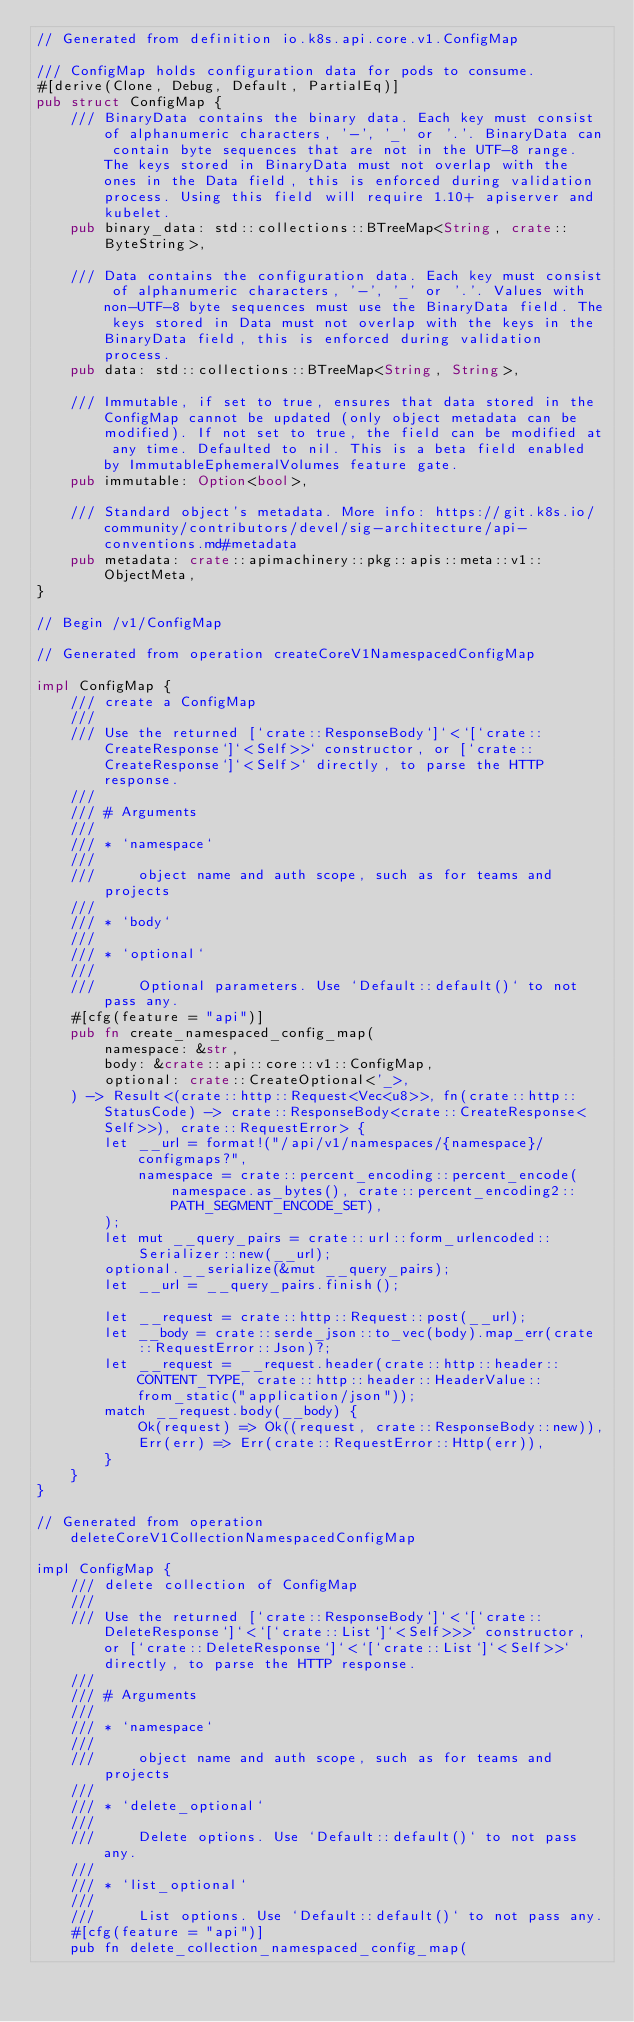<code> <loc_0><loc_0><loc_500><loc_500><_Rust_>// Generated from definition io.k8s.api.core.v1.ConfigMap

/// ConfigMap holds configuration data for pods to consume.
#[derive(Clone, Debug, Default, PartialEq)]
pub struct ConfigMap {
    /// BinaryData contains the binary data. Each key must consist of alphanumeric characters, '-', '_' or '.'. BinaryData can contain byte sequences that are not in the UTF-8 range. The keys stored in BinaryData must not overlap with the ones in the Data field, this is enforced during validation process. Using this field will require 1.10+ apiserver and kubelet.
    pub binary_data: std::collections::BTreeMap<String, crate::ByteString>,

    /// Data contains the configuration data. Each key must consist of alphanumeric characters, '-', '_' or '.'. Values with non-UTF-8 byte sequences must use the BinaryData field. The keys stored in Data must not overlap with the keys in the BinaryData field, this is enforced during validation process.
    pub data: std::collections::BTreeMap<String, String>,

    /// Immutable, if set to true, ensures that data stored in the ConfigMap cannot be updated (only object metadata can be modified). If not set to true, the field can be modified at any time. Defaulted to nil. This is a beta field enabled by ImmutableEphemeralVolumes feature gate.
    pub immutable: Option<bool>,

    /// Standard object's metadata. More info: https://git.k8s.io/community/contributors/devel/sig-architecture/api-conventions.md#metadata
    pub metadata: crate::apimachinery::pkg::apis::meta::v1::ObjectMeta,
}

// Begin /v1/ConfigMap

// Generated from operation createCoreV1NamespacedConfigMap

impl ConfigMap {
    /// create a ConfigMap
    ///
    /// Use the returned [`crate::ResponseBody`]`<`[`crate::CreateResponse`]`<Self>>` constructor, or [`crate::CreateResponse`]`<Self>` directly, to parse the HTTP response.
    ///
    /// # Arguments
    ///
    /// * `namespace`
    ///
    ///     object name and auth scope, such as for teams and projects
    ///
    /// * `body`
    ///
    /// * `optional`
    ///
    ///     Optional parameters. Use `Default::default()` to not pass any.
    #[cfg(feature = "api")]
    pub fn create_namespaced_config_map(
        namespace: &str,
        body: &crate::api::core::v1::ConfigMap,
        optional: crate::CreateOptional<'_>,
    ) -> Result<(crate::http::Request<Vec<u8>>, fn(crate::http::StatusCode) -> crate::ResponseBody<crate::CreateResponse<Self>>), crate::RequestError> {
        let __url = format!("/api/v1/namespaces/{namespace}/configmaps?",
            namespace = crate::percent_encoding::percent_encode(namespace.as_bytes(), crate::percent_encoding2::PATH_SEGMENT_ENCODE_SET),
        );
        let mut __query_pairs = crate::url::form_urlencoded::Serializer::new(__url);
        optional.__serialize(&mut __query_pairs);
        let __url = __query_pairs.finish();

        let __request = crate::http::Request::post(__url);
        let __body = crate::serde_json::to_vec(body).map_err(crate::RequestError::Json)?;
        let __request = __request.header(crate::http::header::CONTENT_TYPE, crate::http::header::HeaderValue::from_static("application/json"));
        match __request.body(__body) {
            Ok(request) => Ok((request, crate::ResponseBody::new)),
            Err(err) => Err(crate::RequestError::Http(err)),
        }
    }
}

// Generated from operation deleteCoreV1CollectionNamespacedConfigMap

impl ConfigMap {
    /// delete collection of ConfigMap
    ///
    /// Use the returned [`crate::ResponseBody`]`<`[`crate::DeleteResponse`]`<`[`crate::List`]`<Self>>>` constructor, or [`crate::DeleteResponse`]`<`[`crate::List`]`<Self>>` directly, to parse the HTTP response.
    ///
    /// # Arguments
    ///
    /// * `namespace`
    ///
    ///     object name and auth scope, such as for teams and projects
    ///
    /// * `delete_optional`
    ///
    ///     Delete options. Use `Default::default()` to not pass any.
    ///
    /// * `list_optional`
    ///
    ///     List options. Use `Default::default()` to not pass any.
    #[cfg(feature = "api")]
    pub fn delete_collection_namespaced_config_map(</code> 